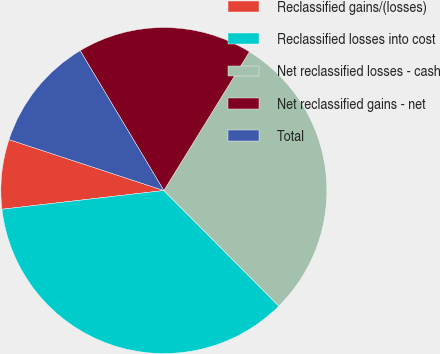Convert chart. <chart><loc_0><loc_0><loc_500><loc_500><pie_chart><fcel>Reclassified gains/(losses)<fcel>Reclassified losses into cost<fcel>Net reclassified losses - cash<fcel>Net reclassified gains - net<fcel>Total<nl><fcel>6.89%<fcel>35.63%<fcel>28.74%<fcel>17.38%<fcel>11.36%<nl></chart> 